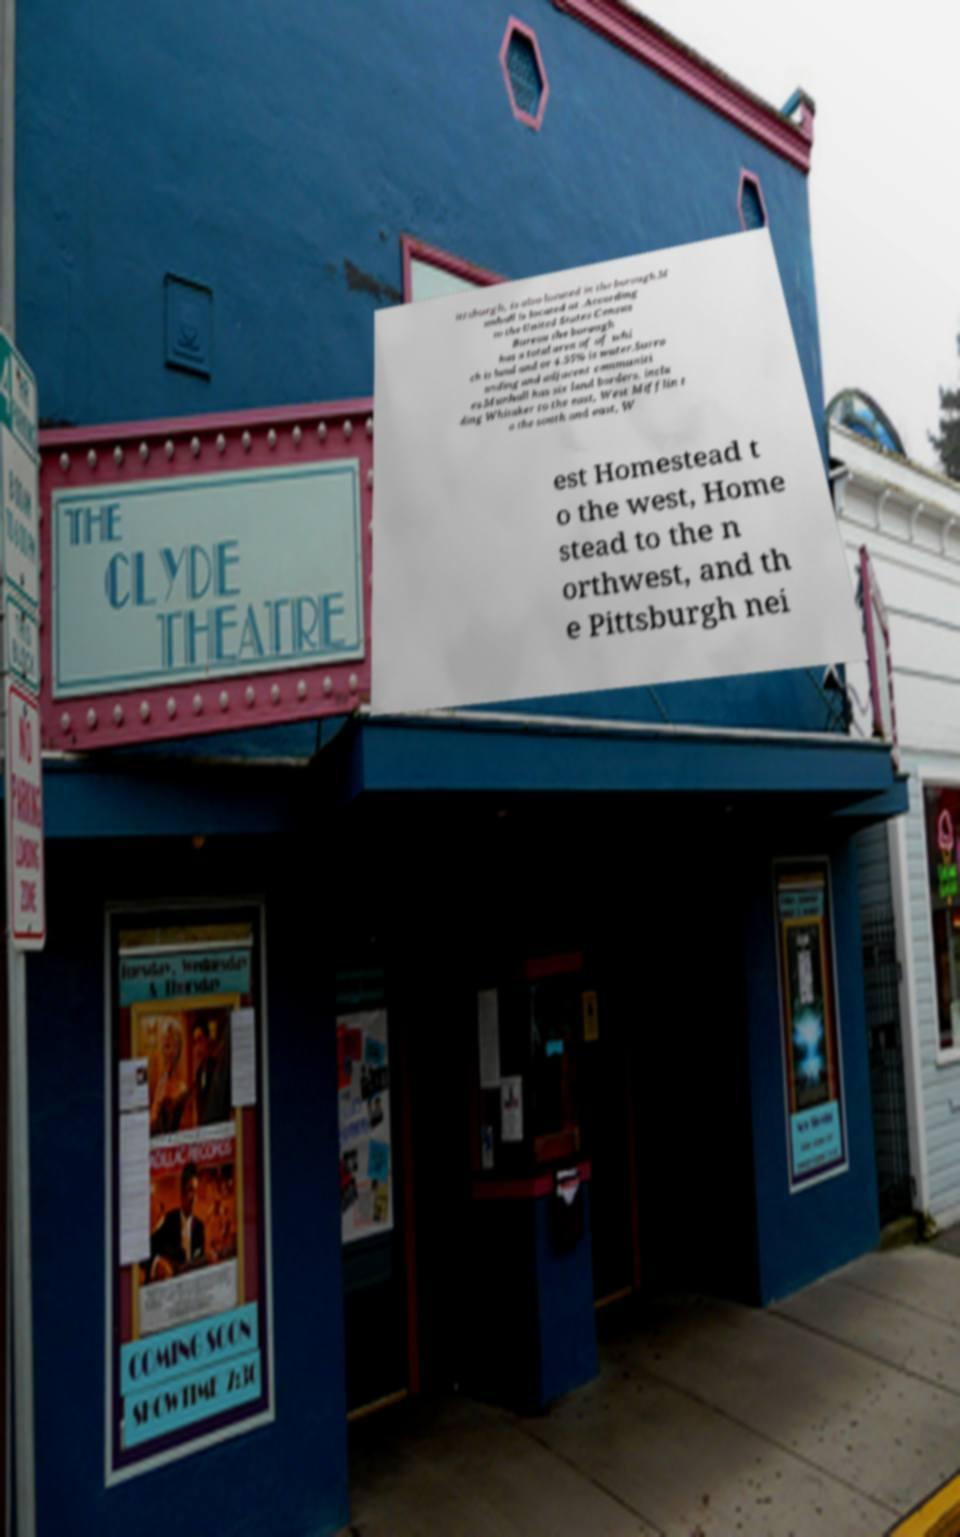I need the written content from this picture converted into text. Can you do that? ittsburgh, is also located in the borough.M unhall is located at .According to the United States Census Bureau the borough has a total area of of whi ch is land and or 4.55% is water.Surro unding and adjacent communiti es.Munhall has six land borders, inclu ding Whitaker to the east, West Mifflin t o the south and east, W est Homestead t o the west, Home stead to the n orthwest, and th e Pittsburgh nei 